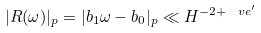<formula> <loc_0><loc_0><loc_500><loc_500>| R ( \omega ) | _ { p } = | b _ { 1 } \omega - b _ { 0 } | _ { p } \ll H ^ { - 2 + \ v e ^ { \prime } }</formula> 